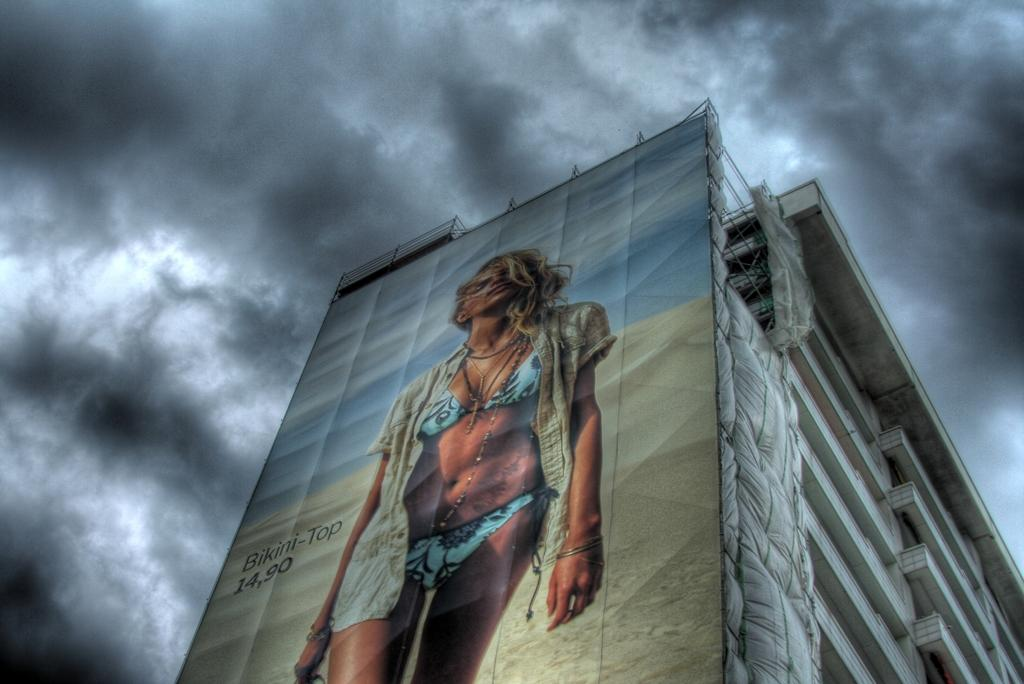What is on the building in the image? There is a board on a building in the image. What can be seen on the board? There is text and a picture of a lady on the board. What is visible in the background of the image? There are clouds in the sky in the background of the image. How many horses are depicted on the board in the image? There are no horses depicted on the board in the image; it features a picture of a lady. Can you tell me if the lady on the board is crying? There is no indication of the lady's emotions on the board in the image. 